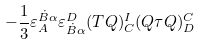Convert formula to latex. <formula><loc_0><loc_0><loc_500><loc_500>- \frac { 1 } { 3 } \varepsilon _ { A } ^ { \dot { B } \alpha } \varepsilon ^ { D } _ { \dot { B } \alpha } ( T Q ) ^ { I } _ { C } ( Q \tau Q ) ^ { C } _ { D }</formula> 